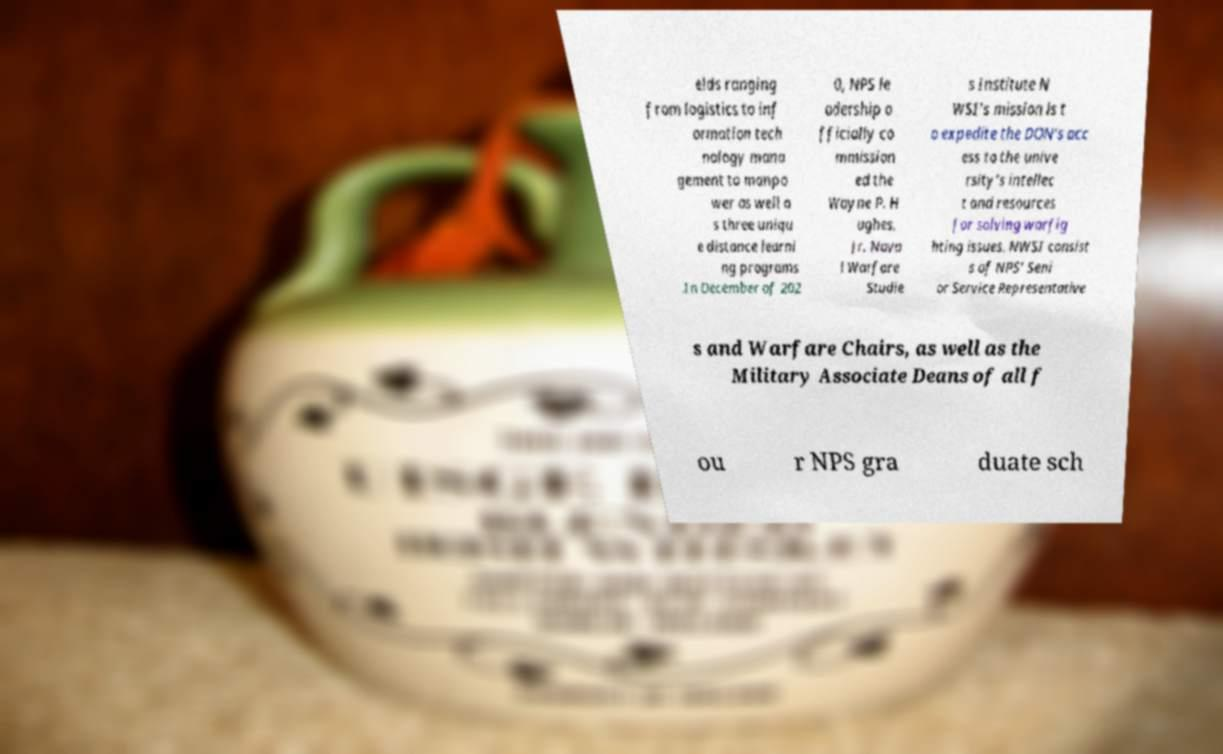Could you assist in decoding the text presented in this image and type it out clearly? elds ranging from logistics to inf ormation tech nology mana gement to manpo wer as well a s three uniqu e distance learni ng programs .In December of 202 0, NPS le adership o fficially co mmission ed the Wayne P. H ughes, Jr. Nava l Warfare Studie s Institute N WSI’s mission is t o expedite the DON’s acc ess to the unive rsity’s intellec t and resources for solving warfig hting issues. NWSI consist s of NPS’ Seni or Service Representative s and Warfare Chairs, as well as the Military Associate Deans of all f ou r NPS gra duate sch 